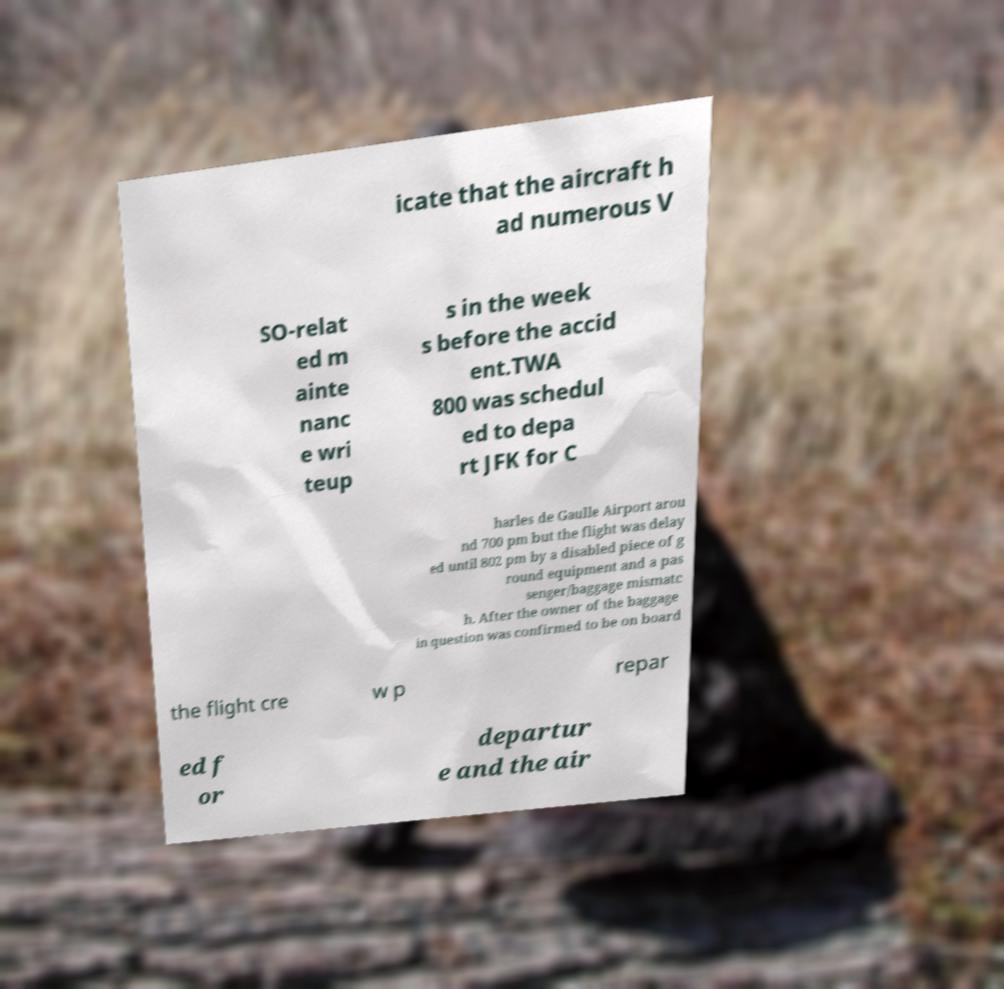Please identify and transcribe the text found in this image. icate that the aircraft h ad numerous V SO-relat ed m ainte nanc e wri teup s in the week s before the accid ent.TWA 800 was schedul ed to depa rt JFK for C harles de Gaulle Airport arou nd 700 pm but the flight was delay ed until 802 pm by a disabled piece of g round equipment and a pas senger/baggage mismatc h. After the owner of the baggage in question was confirmed to be on board the flight cre w p repar ed f or departur e and the air 